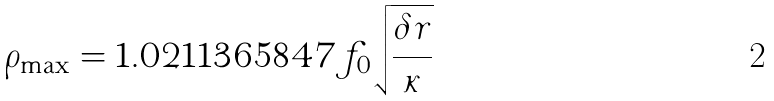Convert formula to latex. <formula><loc_0><loc_0><loc_500><loc_500>\rho _ { \max } = 1 . 0 2 1 1 3 6 5 8 4 7 f _ { 0 } \sqrt { \frac { \delta r } { \kappa } }</formula> 